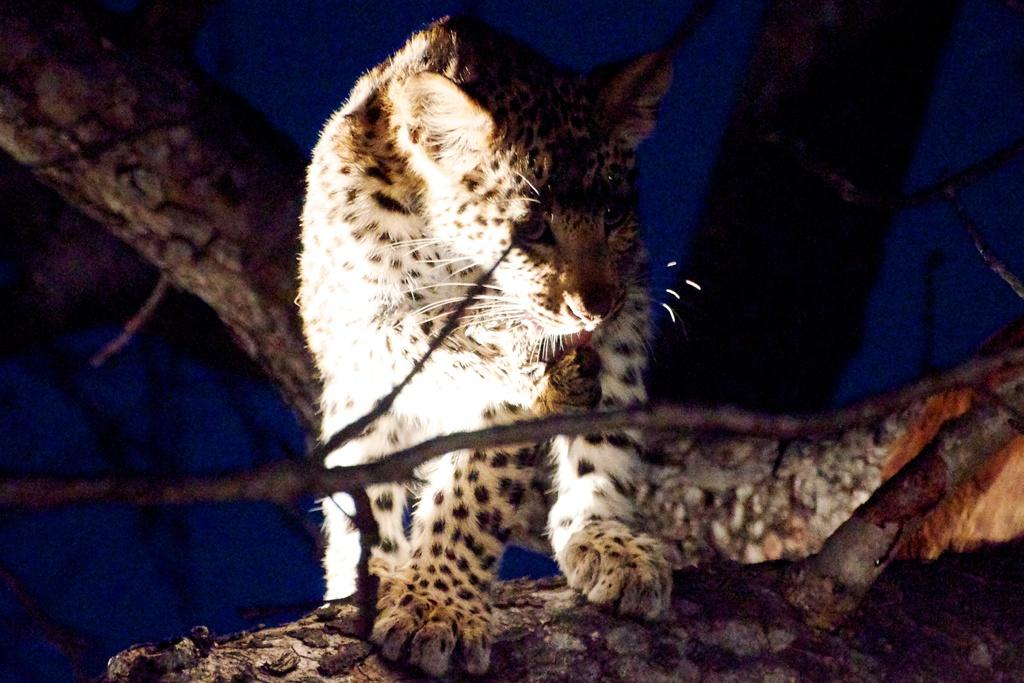What type of animal can be seen in the image? There is an animal in the image, but its specific type cannot be determined from the provided facts. Where is the animal located in the image? The animal is on a tree in the image. What color is the background of the image? The background of the image is blue. How does the company increase its profits in the image? There is no mention of a company or profits in the image; it features an animal on a tree with a blue background. 